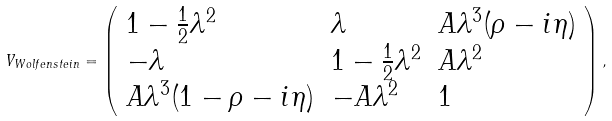<formula> <loc_0><loc_0><loc_500><loc_500>V _ { W o l f e n s t e i n } = \left ( \begin{array} { l l l } 1 - \frac { 1 } { 2 } \lambda ^ { 2 } & \lambda & A \lambda ^ { 3 } ( \rho - i \eta ) \\ - \lambda & 1 - \frac { 1 } { 2 } \lambda ^ { 2 } & A \lambda ^ { 2 } \\ A \lambda ^ { 3 } ( 1 - \rho - i \eta ) & - A \lambda ^ { 2 } & 1 \end{array} \right ) ,</formula> 